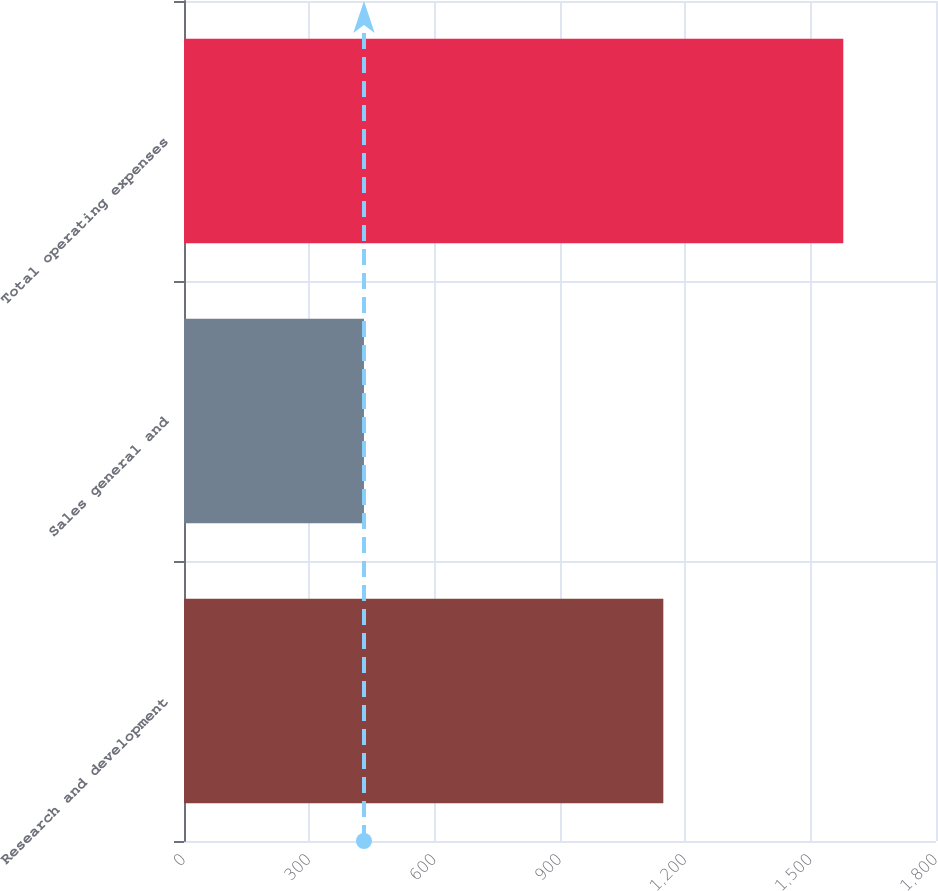<chart> <loc_0><loc_0><loc_500><loc_500><bar_chart><fcel>Research and development<fcel>Sales general and<fcel>Total operating expenses<nl><fcel>1147.3<fcel>430.8<fcel>1578.1<nl></chart> 